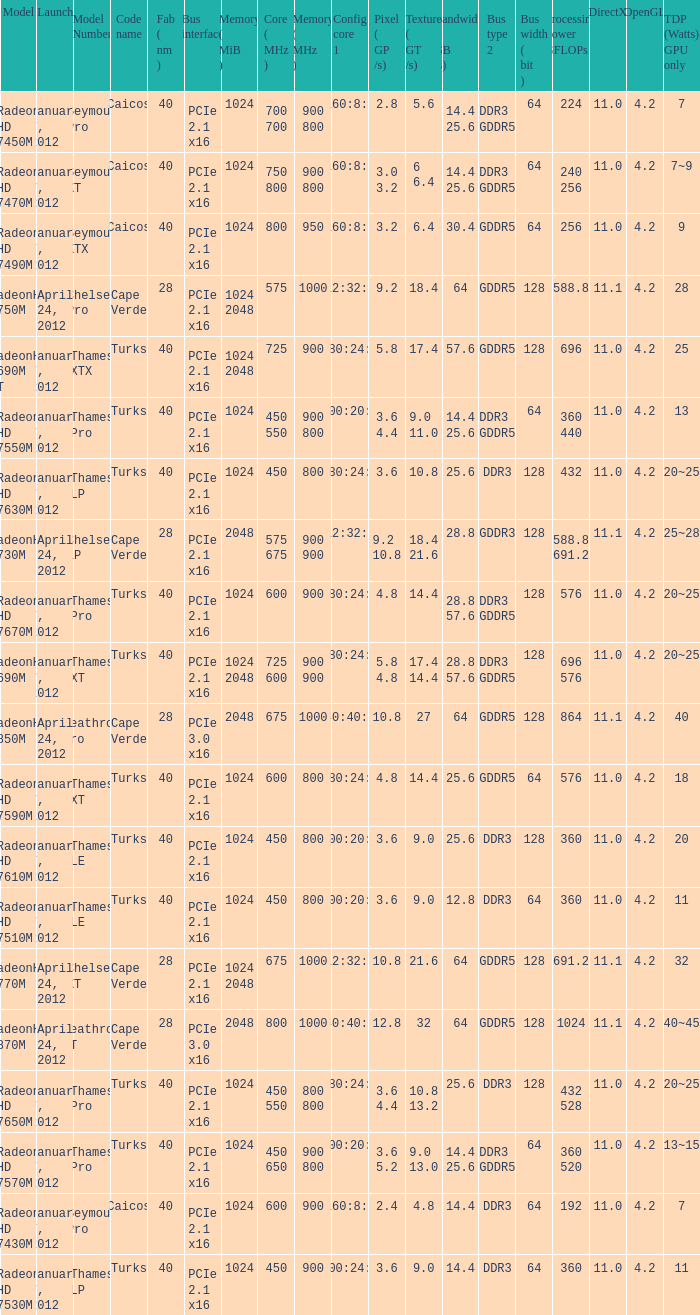What was the maximum fab (nm)? 40.0. 